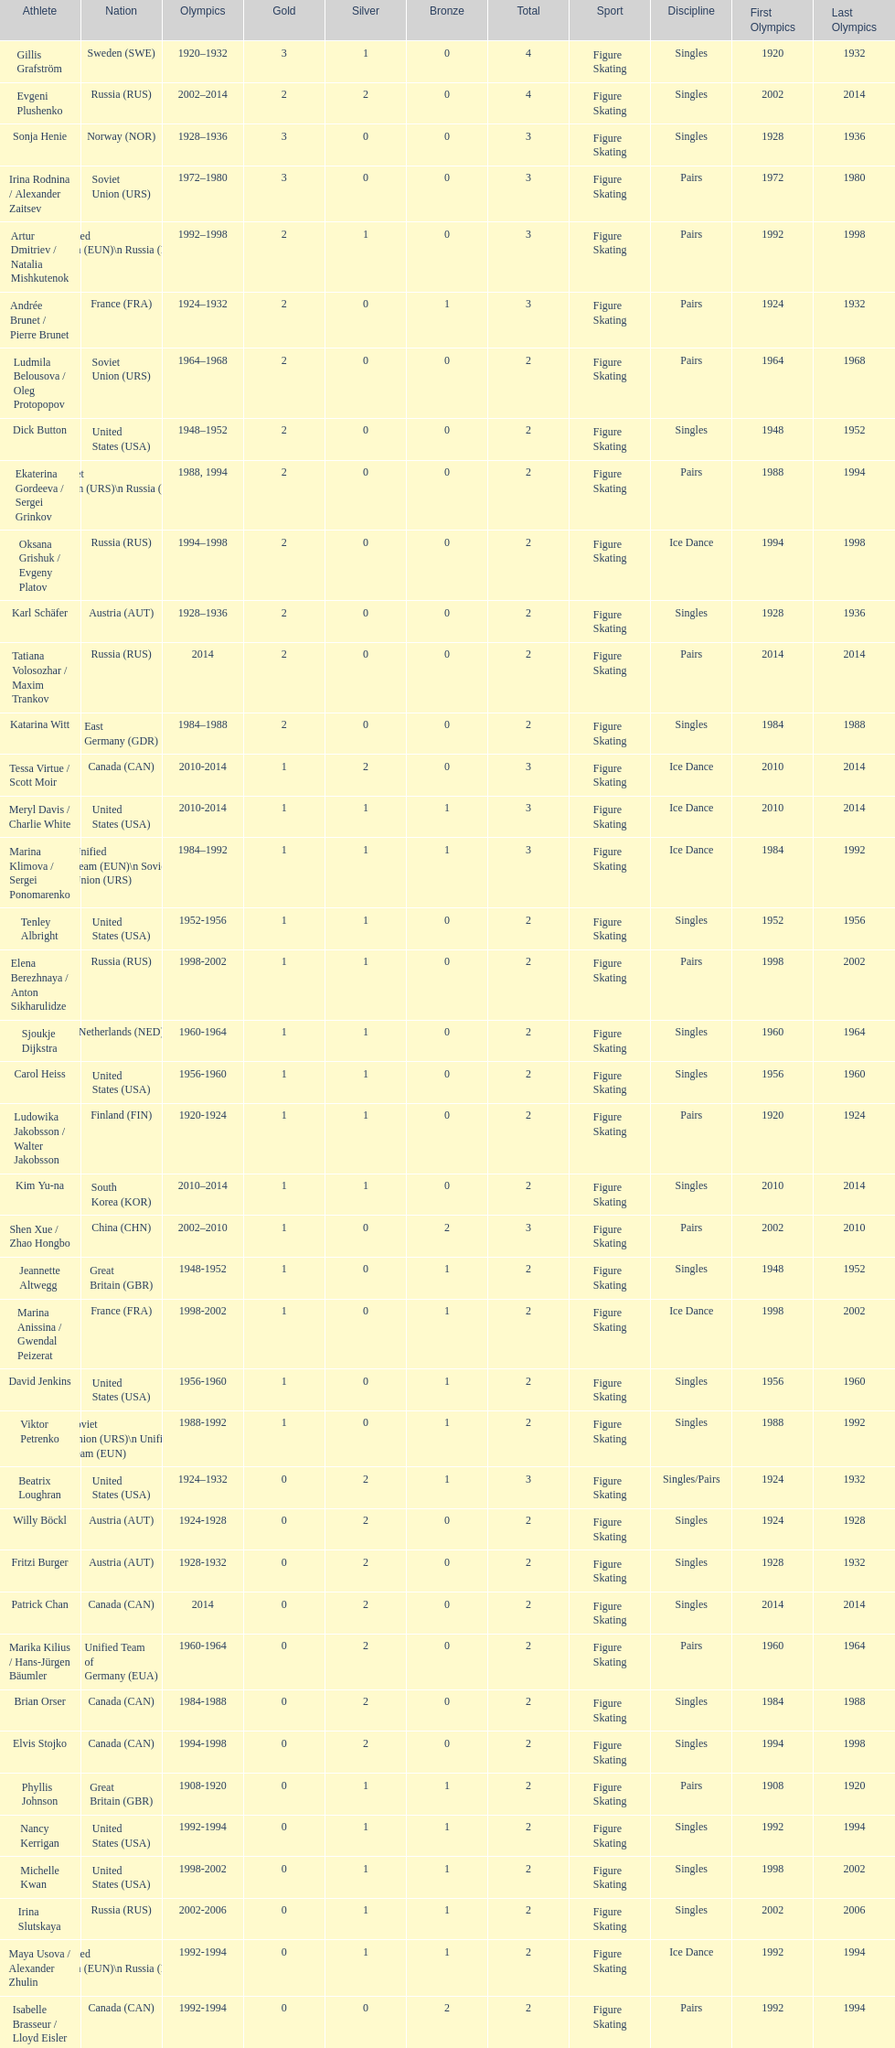Following 2010, which athletic individual originated from south korea? Kim Yu-na. 